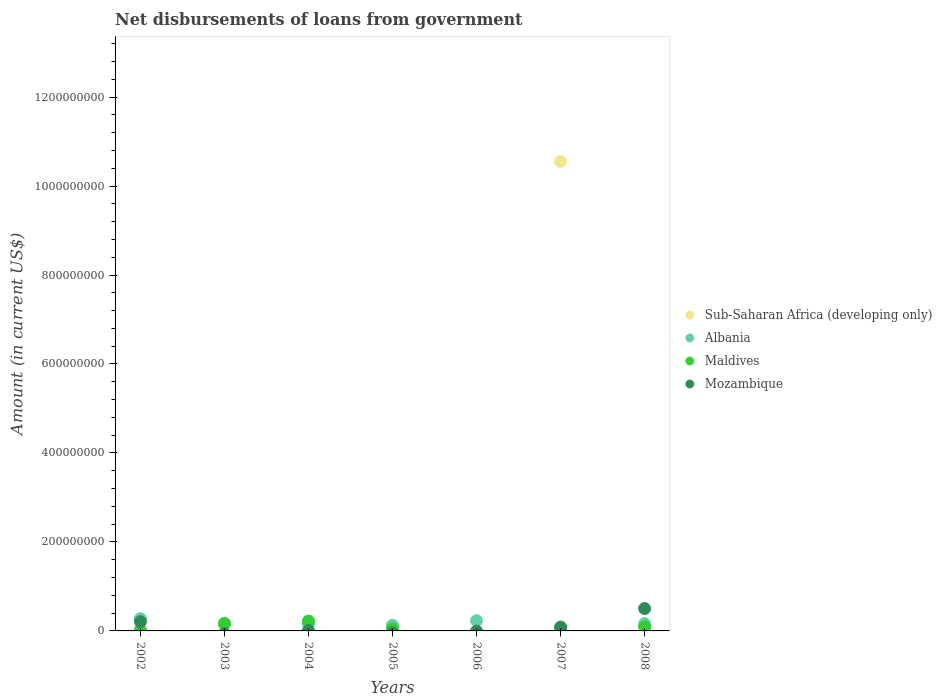How many different coloured dotlines are there?
Provide a succinct answer. 4. What is the amount of loan disbursed from government in Sub-Saharan Africa (developing only) in 2003?
Provide a succinct answer. 0. Across all years, what is the maximum amount of loan disbursed from government in Maldives?
Offer a very short reply. 2.21e+07. Across all years, what is the minimum amount of loan disbursed from government in Albania?
Give a very brief answer. 7.23e+06. In which year was the amount of loan disbursed from government in Mozambique maximum?
Offer a terse response. 2008. What is the total amount of loan disbursed from government in Albania in the graph?
Make the answer very short. 1.20e+08. What is the difference between the amount of loan disbursed from government in Albania in 2002 and that in 2007?
Keep it short and to the point. 2.02e+07. What is the difference between the amount of loan disbursed from government in Sub-Saharan Africa (developing only) in 2002 and the amount of loan disbursed from government in Albania in 2005?
Provide a short and direct response. -1.28e+07. What is the average amount of loan disbursed from government in Maldives per year?
Your response must be concise. 7.68e+06. In the year 2004, what is the difference between the amount of loan disbursed from government in Mozambique and amount of loan disbursed from government in Maldives?
Your answer should be compact. -2.10e+07. What is the ratio of the amount of loan disbursed from government in Mozambique in 2007 to that in 2008?
Keep it short and to the point. 0.17. Is the amount of loan disbursed from government in Mozambique in 2002 less than that in 2004?
Give a very brief answer. No. Is the difference between the amount of loan disbursed from government in Mozambique in 2002 and 2008 greater than the difference between the amount of loan disbursed from government in Maldives in 2002 and 2008?
Provide a succinct answer. No. What is the difference between the highest and the second highest amount of loan disbursed from government in Maldives?
Your answer should be compact. 5.96e+06. What is the difference between the highest and the lowest amount of loan disbursed from government in Maldives?
Ensure brevity in your answer.  2.21e+07. Is the amount of loan disbursed from government in Mozambique strictly greater than the amount of loan disbursed from government in Sub-Saharan Africa (developing only) over the years?
Your response must be concise. No. How many dotlines are there?
Keep it short and to the point. 4. What is the difference between two consecutive major ticks on the Y-axis?
Offer a terse response. 2.00e+08. Where does the legend appear in the graph?
Keep it short and to the point. Center right. How are the legend labels stacked?
Ensure brevity in your answer.  Vertical. What is the title of the graph?
Give a very brief answer. Net disbursements of loans from government. What is the label or title of the X-axis?
Your answer should be very brief. Years. What is the label or title of the Y-axis?
Your answer should be very brief. Amount (in current US$). What is the Amount (in current US$) in Sub-Saharan Africa (developing only) in 2002?
Give a very brief answer. 0. What is the Amount (in current US$) in Albania in 2002?
Your response must be concise. 2.74e+07. What is the Amount (in current US$) in Maldives in 2002?
Make the answer very short. 1.83e+06. What is the Amount (in current US$) of Mozambique in 2002?
Your answer should be very brief. 2.09e+07. What is the Amount (in current US$) of Sub-Saharan Africa (developing only) in 2003?
Give a very brief answer. 0. What is the Amount (in current US$) of Albania in 2003?
Provide a short and direct response. 1.72e+07. What is the Amount (in current US$) in Maldives in 2003?
Provide a short and direct response. 1.61e+07. What is the Amount (in current US$) of Albania in 2004?
Offer a terse response. 1.58e+07. What is the Amount (in current US$) of Maldives in 2004?
Offer a terse response. 2.21e+07. What is the Amount (in current US$) of Mozambique in 2004?
Your answer should be compact. 1.05e+06. What is the Amount (in current US$) in Albania in 2005?
Provide a short and direct response. 1.28e+07. What is the Amount (in current US$) in Maldives in 2005?
Your answer should be very brief. 4.68e+06. What is the Amount (in current US$) of Albania in 2006?
Give a very brief answer. 2.31e+07. What is the Amount (in current US$) of Mozambique in 2006?
Offer a terse response. 0. What is the Amount (in current US$) in Sub-Saharan Africa (developing only) in 2007?
Your response must be concise. 1.06e+09. What is the Amount (in current US$) in Albania in 2007?
Provide a short and direct response. 7.23e+06. What is the Amount (in current US$) of Maldives in 2007?
Your answer should be compact. 0. What is the Amount (in current US$) in Mozambique in 2007?
Your answer should be compact. 8.58e+06. What is the Amount (in current US$) of Albania in 2008?
Provide a short and direct response. 1.64e+07. What is the Amount (in current US$) of Maldives in 2008?
Your response must be concise. 9.06e+06. What is the Amount (in current US$) of Mozambique in 2008?
Offer a very short reply. 5.03e+07. Across all years, what is the maximum Amount (in current US$) in Sub-Saharan Africa (developing only)?
Provide a short and direct response. 1.06e+09. Across all years, what is the maximum Amount (in current US$) of Albania?
Provide a short and direct response. 2.74e+07. Across all years, what is the maximum Amount (in current US$) of Maldives?
Give a very brief answer. 2.21e+07. Across all years, what is the maximum Amount (in current US$) of Mozambique?
Provide a short and direct response. 5.03e+07. Across all years, what is the minimum Amount (in current US$) of Sub-Saharan Africa (developing only)?
Your response must be concise. 0. Across all years, what is the minimum Amount (in current US$) of Albania?
Your answer should be very brief. 7.23e+06. Across all years, what is the minimum Amount (in current US$) of Mozambique?
Offer a very short reply. 0. What is the total Amount (in current US$) of Sub-Saharan Africa (developing only) in the graph?
Offer a very short reply. 1.06e+09. What is the total Amount (in current US$) in Albania in the graph?
Provide a short and direct response. 1.20e+08. What is the total Amount (in current US$) of Maldives in the graph?
Keep it short and to the point. 5.38e+07. What is the total Amount (in current US$) in Mozambique in the graph?
Give a very brief answer. 8.09e+07. What is the difference between the Amount (in current US$) of Albania in 2002 and that in 2003?
Ensure brevity in your answer.  1.03e+07. What is the difference between the Amount (in current US$) in Maldives in 2002 and that in 2003?
Your response must be concise. -1.43e+07. What is the difference between the Amount (in current US$) in Albania in 2002 and that in 2004?
Provide a succinct answer. 1.16e+07. What is the difference between the Amount (in current US$) in Maldives in 2002 and that in 2004?
Provide a short and direct response. -2.03e+07. What is the difference between the Amount (in current US$) of Mozambique in 2002 and that in 2004?
Give a very brief answer. 1.99e+07. What is the difference between the Amount (in current US$) of Albania in 2002 and that in 2005?
Keep it short and to the point. 1.46e+07. What is the difference between the Amount (in current US$) in Maldives in 2002 and that in 2005?
Give a very brief answer. -2.86e+06. What is the difference between the Amount (in current US$) in Albania in 2002 and that in 2006?
Provide a short and direct response. 4.38e+06. What is the difference between the Amount (in current US$) of Albania in 2002 and that in 2007?
Provide a succinct answer. 2.02e+07. What is the difference between the Amount (in current US$) in Mozambique in 2002 and that in 2007?
Ensure brevity in your answer.  1.23e+07. What is the difference between the Amount (in current US$) in Albania in 2002 and that in 2008?
Your answer should be compact. 1.10e+07. What is the difference between the Amount (in current US$) of Maldives in 2002 and that in 2008?
Ensure brevity in your answer.  -7.24e+06. What is the difference between the Amount (in current US$) in Mozambique in 2002 and that in 2008?
Provide a succinct answer. -2.94e+07. What is the difference between the Amount (in current US$) in Albania in 2003 and that in 2004?
Your answer should be very brief. 1.37e+06. What is the difference between the Amount (in current US$) in Maldives in 2003 and that in 2004?
Keep it short and to the point. -5.96e+06. What is the difference between the Amount (in current US$) of Albania in 2003 and that in 2005?
Provide a short and direct response. 4.38e+06. What is the difference between the Amount (in current US$) of Maldives in 2003 and that in 2005?
Make the answer very short. 1.14e+07. What is the difference between the Amount (in current US$) of Albania in 2003 and that in 2006?
Provide a short and direct response. -5.89e+06. What is the difference between the Amount (in current US$) of Albania in 2003 and that in 2007?
Make the answer very short. 9.95e+06. What is the difference between the Amount (in current US$) of Albania in 2003 and that in 2008?
Make the answer very short. 7.38e+05. What is the difference between the Amount (in current US$) of Maldives in 2003 and that in 2008?
Provide a succinct answer. 7.06e+06. What is the difference between the Amount (in current US$) of Albania in 2004 and that in 2005?
Your answer should be very brief. 3.01e+06. What is the difference between the Amount (in current US$) in Maldives in 2004 and that in 2005?
Your response must be concise. 1.74e+07. What is the difference between the Amount (in current US$) of Albania in 2004 and that in 2006?
Your answer should be very brief. -7.26e+06. What is the difference between the Amount (in current US$) of Albania in 2004 and that in 2007?
Give a very brief answer. 8.58e+06. What is the difference between the Amount (in current US$) of Mozambique in 2004 and that in 2007?
Keep it short and to the point. -7.53e+06. What is the difference between the Amount (in current US$) of Albania in 2004 and that in 2008?
Ensure brevity in your answer.  -6.32e+05. What is the difference between the Amount (in current US$) of Maldives in 2004 and that in 2008?
Your answer should be compact. 1.30e+07. What is the difference between the Amount (in current US$) of Mozambique in 2004 and that in 2008?
Offer a terse response. -4.92e+07. What is the difference between the Amount (in current US$) of Albania in 2005 and that in 2006?
Your answer should be very brief. -1.03e+07. What is the difference between the Amount (in current US$) in Albania in 2005 and that in 2007?
Provide a succinct answer. 5.57e+06. What is the difference between the Amount (in current US$) of Albania in 2005 and that in 2008?
Provide a succinct answer. -3.64e+06. What is the difference between the Amount (in current US$) in Maldives in 2005 and that in 2008?
Provide a succinct answer. -4.38e+06. What is the difference between the Amount (in current US$) of Albania in 2006 and that in 2007?
Your response must be concise. 1.58e+07. What is the difference between the Amount (in current US$) of Albania in 2006 and that in 2008?
Your answer should be compact. 6.63e+06. What is the difference between the Amount (in current US$) in Albania in 2007 and that in 2008?
Provide a short and direct response. -9.21e+06. What is the difference between the Amount (in current US$) in Mozambique in 2007 and that in 2008?
Offer a very short reply. -4.17e+07. What is the difference between the Amount (in current US$) of Albania in 2002 and the Amount (in current US$) of Maldives in 2003?
Make the answer very short. 1.13e+07. What is the difference between the Amount (in current US$) of Albania in 2002 and the Amount (in current US$) of Maldives in 2004?
Keep it short and to the point. 5.36e+06. What is the difference between the Amount (in current US$) in Albania in 2002 and the Amount (in current US$) in Mozambique in 2004?
Provide a short and direct response. 2.64e+07. What is the difference between the Amount (in current US$) of Maldives in 2002 and the Amount (in current US$) of Mozambique in 2004?
Your answer should be compact. 7.73e+05. What is the difference between the Amount (in current US$) of Albania in 2002 and the Amount (in current US$) of Maldives in 2005?
Make the answer very short. 2.28e+07. What is the difference between the Amount (in current US$) in Albania in 2002 and the Amount (in current US$) in Mozambique in 2007?
Keep it short and to the point. 1.89e+07. What is the difference between the Amount (in current US$) of Maldives in 2002 and the Amount (in current US$) of Mozambique in 2007?
Make the answer very short. -6.76e+06. What is the difference between the Amount (in current US$) in Albania in 2002 and the Amount (in current US$) in Maldives in 2008?
Provide a short and direct response. 1.84e+07. What is the difference between the Amount (in current US$) in Albania in 2002 and the Amount (in current US$) in Mozambique in 2008?
Give a very brief answer. -2.29e+07. What is the difference between the Amount (in current US$) in Maldives in 2002 and the Amount (in current US$) in Mozambique in 2008?
Your response must be concise. -4.85e+07. What is the difference between the Amount (in current US$) of Albania in 2003 and the Amount (in current US$) of Maldives in 2004?
Keep it short and to the point. -4.91e+06. What is the difference between the Amount (in current US$) of Albania in 2003 and the Amount (in current US$) of Mozambique in 2004?
Ensure brevity in your answer.  1.61e+07. What is the difference between the Amount (in current US$) of Maldives in 2003 and the Amount (in current US$) of Mozambique in 2004?
Offer a very short reply. 1.51e+07. What is the difference between the Amount (in current US$) of Albania in 2003 and the Amount (in current US$) of Maldives in 2005?
Your response must be concise. 1.25e+07. What is the difference between the Amount (in current US$) in Albania in 2003 and the Amount (in current US$) in Mozambique in 2007?
Offer a very short reply. 8.59e+06. What is the difference between the Amount (in current US$) of Maldives in 2003 and the Amount (in current US$) of Mozambique in 2007?
Offer a terse response. 7.54e+06. What is the difference between the Amount (in current US$) of Albania in 2003 and the Amount (in current US$) of Maldives in 2008?
Provide a succinct answer. 8.11e+06. What is the difference between the Amount (in current US$) in Albania in 2003 and the Amount (in current US$) in Mozambique in 2008?
Provide a short and direct response. -3.31e+07. What is the difference between the Amount (in current US$) in Maldives in 2003 and the Amount (in current US$) in Mozambique in 2008?
Give a very brief answer. -3.42e+07. What is the difference between the Amount (in current US$) of Albania in 2004 and the Amount (in current US$) of Maldives in 2005?
Ensure brevity in your answer.  1.11e+07. What is the difference between the Amount (in current US$) in Albania in 2004 and the Amount (in current US$) in Mozambique in 2007?
Give a very brief answer. 7.22e+06. What is the difference between the Amount (in current US$) of Maldives in 2004 and the Amount (in current US$) of Mozambique in 2007?
Provide a succinct answer. 1.35e+07. What is the difference between the Amount (in current US$) in Albania in 2004 and the Amount (in current US$) in Maldives in 2008?
Give a very brief answer. 6.74e+06. What is the difference between the Amount (in current US$) in Albania in 2004 and the Amount (in current US$) in Mozambique in 2008?
Offer a terse response. -3.45e+07. What is the difference between the Amount (in current US$) in Maldives in 2004 and the Amount (in current US$) in Mozambique in 2008?
Your answer should be very brief. -2.82e+07. What is the difference between the Amount (in current US$) in Albania in 2005 and the Amount (in current US$) in Mozambique in 2007?
Provide a short and direct response. 4.21e+06. What is the difference between the Amount (in current US$) in Maldives in 2005 and the Amount (in current US$) in Mozambique in 2007?
Make the answer very short. -3.90e+06. What is the difference between the Amount (in current US$) in Albania in 2005 and the Amount (in current US$) in Maldives in 2008?
Your answer should be very brief. 3.73e+06. What is the difference between the Amount (in current US$) of Albania in 2005 and the Amount (in current US$) of Mozambique in 2008?
Ensure brevity in your answer.  -3.75e+07. What is the difference between the Amount (in current US$) in Maldives in 2005 and the Amount (in current US$) in Mozambique in 2008?
Offer a very short reply. -4.56e+07. What is the difference between the Amount (in current US$) of Albania in 2006 and the Amount (in current US$) of Mozambique in 2007?
Give a very brief answer. 1.45e+07. What is the difference between the Amount (in current US$) in Albania in 2006 and the Amount (in current US$) in Maldives in 2008?
Your answer should be very brief. 1.40e+07. What is the difference between the Amount (in current US$) of Albania in 2006 and the Amount (in current US$) of Mozambique in 2008?
Keep it short and to the point. -2.72e+07. What is the difference between the Amount (in current US$) in Sub-Saharan Africa (developing only) in 2007 and the Amount (in current US$) in Albania in 2008?
Give a very brief answer. 1.04e+09. What is the difference between the Amount (in current US$) of Sub-Saharan Africa (developing only) in 2007 and the Amount (in current US$) of Maldives in 2008?
Your answer should be very brief. 1.05e+09. What is the difference between the Amount (in current US$) of Sub-Saharan Africa (developing only) in 2007 and the Amount (in current US$) of Mozambique in 2008?
Provide a succinct answer. 1.01e+09. What is the difference between the Amount (in current US$) in Albania in 2007 and the Amount (in current US$) in Maldives in 2008?
Make the answer very short. -1.84e+06. What is the difference between the Amount (in current US$) in Albania in 2007 and the Amount (in current US$) in Mozambique in 2008?
Offer a very short reply. -4.31e+07. What is the average Amount (in current US$) in Sub-Saharan Africa (developing only) per year?
Provide a succinct answer. 1.51e+08. What is the average Amount (in current US$) of Albania per year?
Offer a very short reply. 1.71e+07. What is the average Amount (in current US$) in Maldives per year?
Keep it short and to the point. 7.68e+06. What is the average Amount (in current US$) in Mozambique per year?
Make the answer very short. 1.16e+07. In the year 2002, what is the difference between the Amount (in current US$) in Albania and Amount (in current US$) in Maldives?
Offer a terse response. 2.56e+07. In the year 2002, what is the difference between the Amount (in current US$) in Albania and Amount (in current US$) in Mozambique?
Provide a short and direct response. 6.51e+06. In the year 2002, what is the difference between the Amount (in current US$) in Maldives and Amount (in current US$) in Mozambique?
Provide a succinct answer. -1.91e+07. In the year 2003, what is the difference between the Amount (in current US$) of Albania and Amount (in current US$) of Maldives?
Your answer should be very brief. 1.05e+06. In the year 2004, what is the difference between the Amount (in current US$) of Albania and Amount (in current US$) of Maldives?
Give a very brief answer. -6.28e+06. In the year 2004, what is the difference between the Amount (in current US$) of Albania and Amount (in current US$) of Mozambique?
Provide a succinct answer. 1.48e+07. In the year 2004, what is the difference between the Amount (in current US$) of Maldives and Amount (in current US$) of Mozambique?
Keep it short and to the point. 2.10e+07. In the year 2005, what is the difference between the Amount (in current US$) of Albania and Amount (in current US$) of Maldives?
Provide a short and direct response. 8.11e+06. In the year 2007, what is the difference between the Amount (in current US$) of Sub-Saharan Africa (developing only) and Amount (in current US$) of Albania?
Your answer should be very brief. 1.05e+09. In the year 2007, what is the difference between the Amount (in current US$) in Sub-Saharan Africa (developing only) and Amount (in current US$) in Mozambique?
Ensure brevity in your answer.  1.05e+09. In the year 2007, what is the difference between the Amount (in current US$) of Albania and Amount (in current US$) of Mozambique?
Your response must be concise. -1.36e+06. In the year 2008, what is the difference between the Amount (in current US$) in Albania and Amount (in current US$) in Maldives?
Give a very brief answer. 7.37e+06. In the year 2008, what is the difference between the Amount (in current US$) in Albania and Amount (in current US$) in Mozambique?
Your answer should be compact. -3.39e+07. In the year 2008, what is the difference between the Amount (in current US$) of Maldives and Amount (in current US$) of Mozambique?
Your answer should be compact. -4.12e+07. What is the ratio of the Amount (in current US$) of Albania in 2002 to that in 2003?
Offer a terse response. 1.6. What is the ratio of the Amount (in current US$) of Maldives in 2002 to that in 2003?
Ensure brevity in your answer.  0.11. What is the ratio of the Amount (in current US$) in Albania in 2002 to that in 2004?
Give a very brief answer. 1.74. What is the ratio of the Amount (in current US$) of Maldives in 2002 to that in 2004?
Your response must be concise. 0.08. What is the ratio of the Amount (in current US$) of Mozambique in 2002 to that in 2004?
Make the answer very short. 19.87. What is the ratio of the Amount (in current US$) in Albania in 2002 to that in 2005?
Provide a succinct answer. 2.14. What is the ratio of the Amount (in current US$) in Maldives in 2002 to that in 2005?
Your answer should be very brief. 0.39. What is the ratio of the Amount (in current US$) in Albania in 2002 to that in 2006?
Offer a terse response. 1.19. What is the ratio of the Amount (in current US$) of Albania in 2002 to that in 2007?
Offer a terse response. 3.8. What is the ratio of the Amount (in current US$) of Mozambique in 2002 to that in 2007?
Ensure brevity in your answer.  2.44. What is the ratio of the Amount (in current US$) of Albania in 2002 to that in 2008?
Ensure brevity in your answer.  1.67. What is the ratio of the Amount (in current US$) of Maldives in 2002 to that in 2008?
Make the answer very short. 0.2. What is the ratio of the Amount (in current US$) of Mozambique in 2002 to that in 2008?
Ensure brevity in your answer.  0.42. What is the ratio of the Amount (in current US$) in Albania in 2003 to that in 2004?
Your answer should be very brief. 1.09. What is the ratio of the Amount (in current US$) in Maldives in 2003 to that in 2004?
Keep it short and to the point. 0.73. What is the ratio of the Amount (in current US$) of Albania in 2003 to that in 2005?
Offer a terse response. 1.34. What is the ratio of the Amount (in current US$) in Maldives in 2003 to that in 2005?
Your response must be concise. 3.44. What is the ratio of the Amount (in current US$) in Albania in 2003 to that in 2006?
Your answer should be compact. 0.74. What is the ratio of the Amount (in current US$) of Albania in 2003 to that in 2007?
Provide a succinct answer. 2.38. What is the ratio of the Amount (in current US$) of Albania in 2003 to that in 2008?
Keep it short and to the point. 1.04. What is the ratio of the Amount (in current US$) of Maldives in 2003 to that in 2008?
Your response must be concise. 1.78. What is the ratio of the Amount (in current US$) of Albania in 2004 to that in 2005?
Offer a terse response. 1.24. What is the ratio of the Amount (in current US$) in Maldives in 2004 to that in 2005?
Your answer should be compact. 4.71. What is the ratio of the Amount (in current US$) of Albania in 2004 to that in 2006?
Your response must be concise. 0.69. What is the ratio of the Amount (in current US$) in Albania in 2004 to that in 2007?
Provide a short and direct response. 2.19. What is the ratio of the Amount (in current US$) of Mozambique in 2004 to that in 2007?
Make the answer very short. 0.12. What is the ratio of the Amount (in current US$) of Albania in 2004 to that in 2008?
Your response must be concise. 0.96. What is the ratio of the Amount (in current US$) of Maldives in 2004 to that in 2008?
Offer a terse response. 2.44. What is the ratio of the Amount (in current US$) of Mozambique in 2004 to that in 2008?
Your answer should be very brief. 0.02. What is the ratio of the Amount (in current US$) of Albania in 2005 to that in 2006?
Keep it short and to the point. 0.55. What is the ratio of the Amount (in current US$) in Albania in 2005 to that in 2007?
Provide a succinct answer. 1.77. What is the ratio of the Amount (in current US$) of Albania in 2005 to that in 2008?
Give a very brief answer. 0.78. What is the ratio of the Amount (in current US$) in Maldives in 2005 to that in 2008?
Give a very brief answer. 0.52. What is the ratio of the Amount (in current US$) of Albania in 2006 to that in 2007?
Your answer should be very brief. 3.19. What is the ratio of the Amount (in current US$) of Albania in 2006 to that in 2008?
Offer a very short reply. 1.4. What is the ratio of the Amount (in current US$) in Albania in 2007 to that in 2008?
Your answer should be very brief. 0.44. What is the ratio of the Amount (in current US$) in Mozambique in 2007 to that in 2008?
Ensure brevity in your answer.  0.17. What is the difference between the highest and the second highest Amount (in current US$) of Albania?
Your response must be concise. 4.38e+06. What is the difference between the highest and the second highest Amount (in current US$) of Maldives?
Make the answer very short. 5.96e+06. What is the difference between the highest and the second highest Amount (in current US$) in Mozambique?
Your answer should be very brief. 2.94e+07. What is the difference between the highest and the lowest Amount (in current US$) in Sub-Saharan Africa (developing only)?
Give a very brief answer. 1.06e+09. What is the difference between the highest and the lowest Amount (in current US$) in Albania?
Offer a terse response. 2.02e+07. What is the difference between the highest and the lowest Amount (in current US$) of Maldives?
Your answer should be very brief. 2.21e+07. What is the difference between the highest and the lowest Amount (in current US$) in Mozambique?
Offer a terse response. 5.03e+07. 